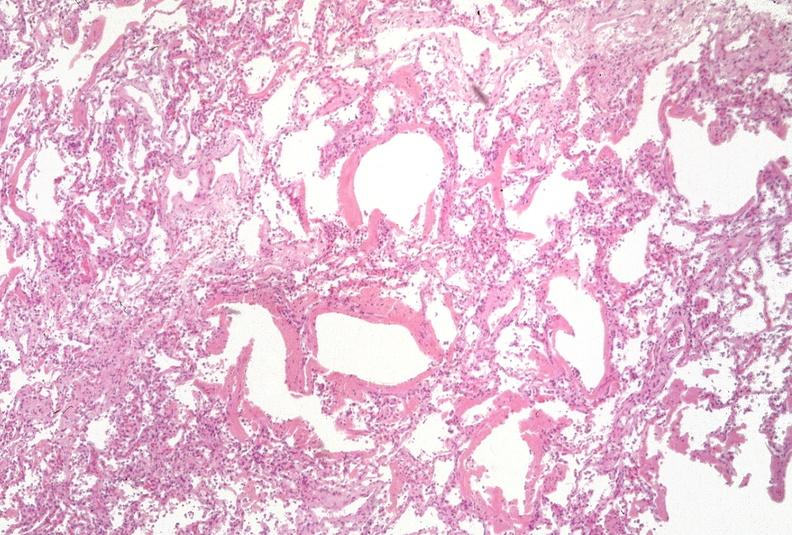where is this?
Answer the question using a single word or phrase. Lung 